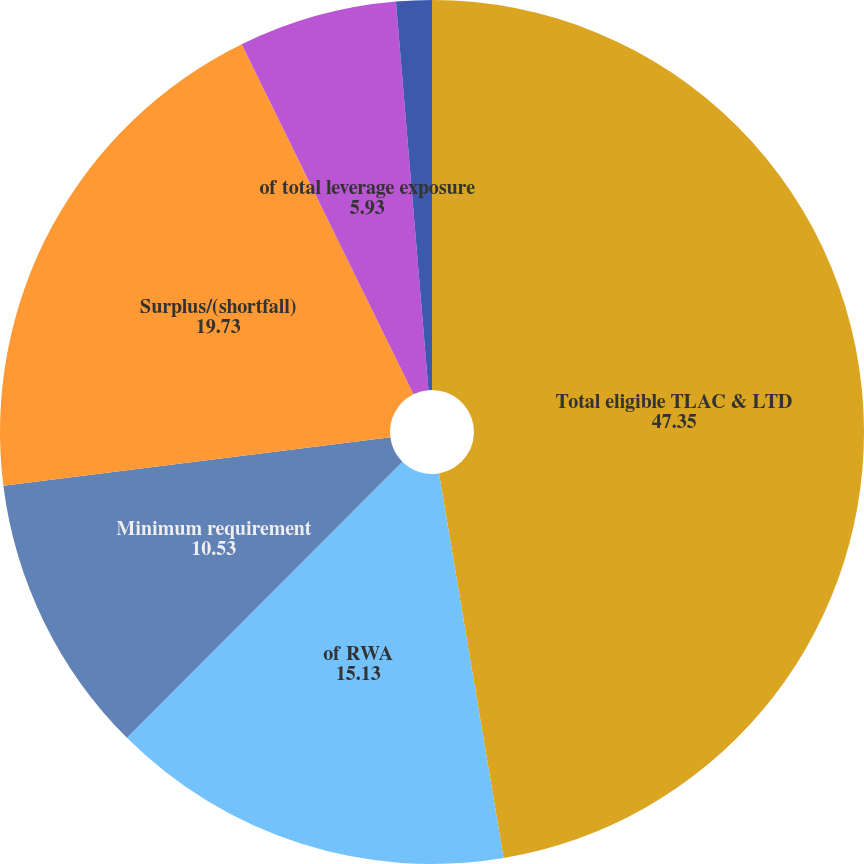<chart> <loc_0><loc_0><loc_500><loc_500><pie_chart><fcel>Total eligible TLAC & LTD<fcel>of RWA<fcel>Minimum requirement<fcel>Surplus/(shortfall)<fcel>of total leverage exposure<fcel>Minimum requirement (a)<nl><fcel>47.35%<fcel>15.13%<fcel>10.53%<fcel>19.73%<fcel>5.93%<fcel>1.33%<nl></chart> 